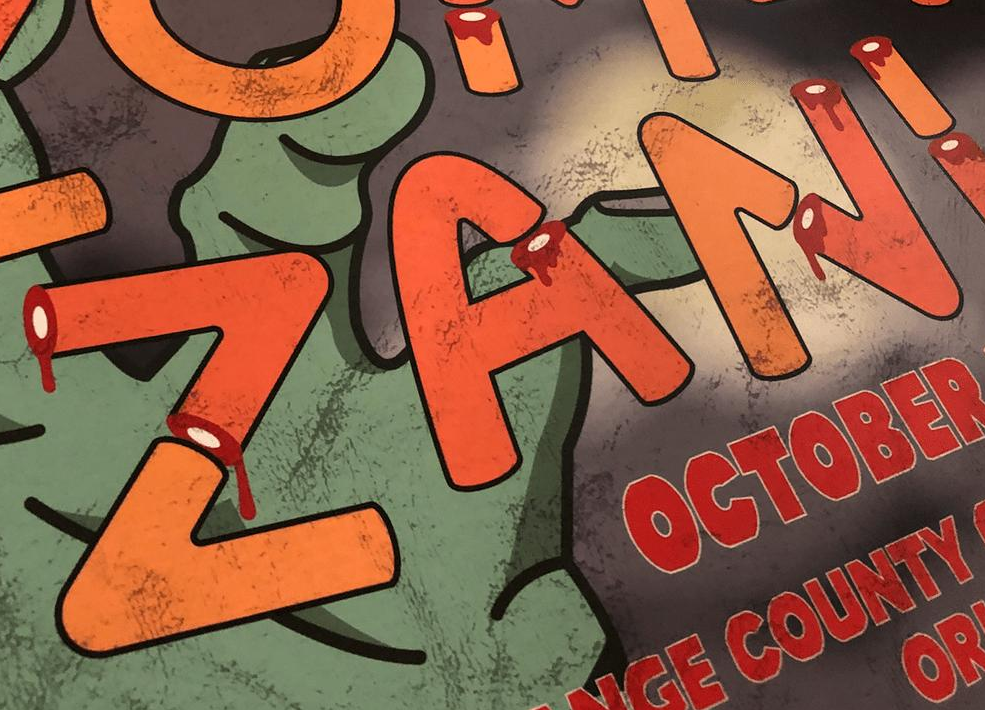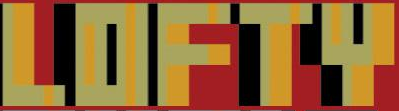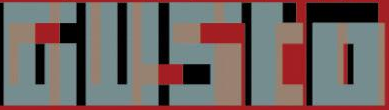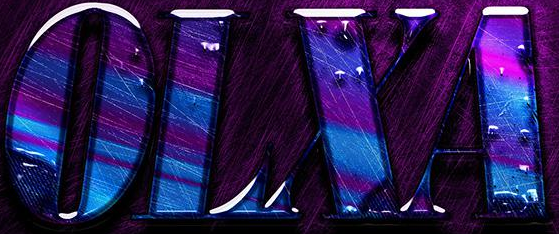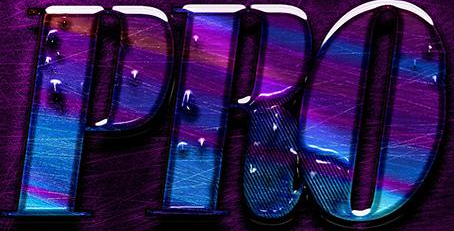What words can you see in these images in sequence, separated by a semicolon? ZANI; LOFTY; GUSto; OLXA; PRO 